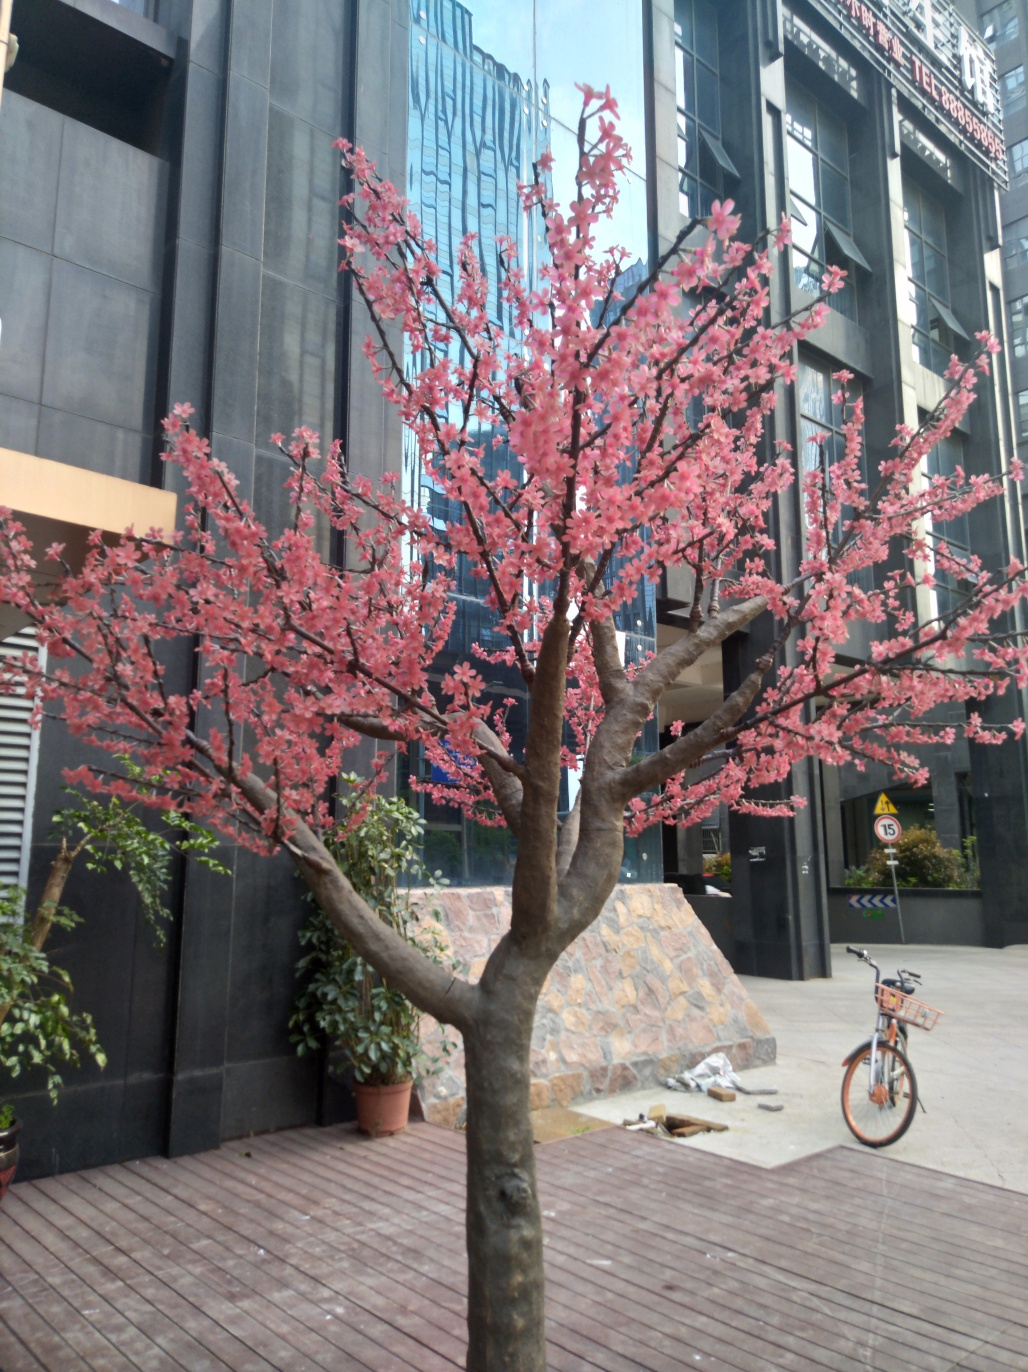What species of tree is this, and are these blossoms a common sight in this area? This tree appears to be a cherry blossom, known for its vibrant pink flowers. Cherry blossoms are indeed a celebrated sight in many regions, particularly in East Asia, and their blooming season is often a time of festivals and gatherings. How long do these blossoms typically last? Cherry blossom blooms are fleeting, often lasting only a couple of weeks. The transience of the blooms has become a symbol of the beauty and ephemerality of life in some cultures. 